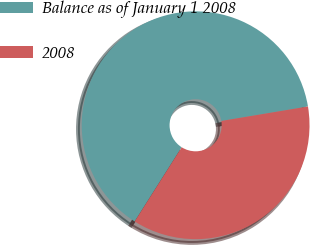Convert chart to OTSL. <chart><loc_0><loc_0><loc_500><loc_500><pie_chart><fcel>Balance as of January 1 2008<fcel>2008<nl><fcel>63.38%<fcel>36.62%<nl></chart> 